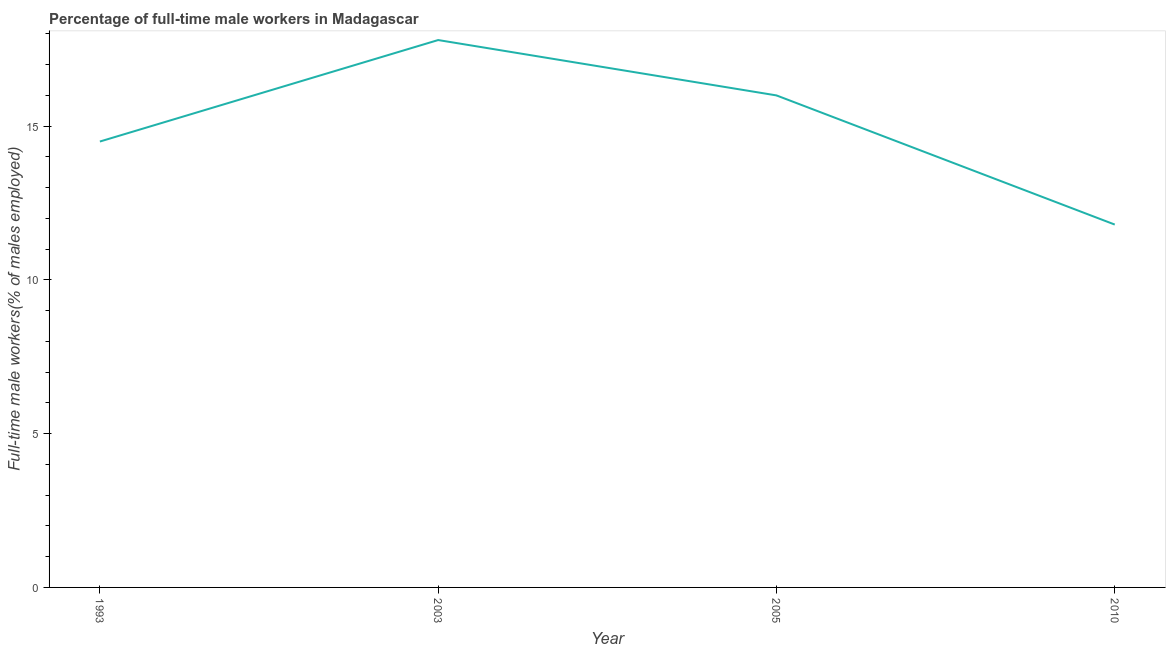What is the percentage of full-time male workers in 2010?
Ensure brevity in your answer.  11.8. Across all years, what is the maximum percentage of full-time male workers?
Ensure brevity in your answer.  17.8. Across all years, what is the minimum percentage of full-time male workers?
Ensure brevity in your answer.  11.8. In which year was the percentage of full-time male workers maximum?
Provide a short and direct response. 2003. What is the sum of the percentage of full-time male workers?
Provide a short and direct response. 60.1. What is the difference between the percentage of full-time male workers in 1993 and 2003?
Make the answer very short. -3.3. What is the average percentage of full-time male workers per year?
Provide a short and direct response. 15.02. What is the median percentage of full-time male workers?
Provide a short and direct response. 15.25. In how many years, is the percentage of full-time male workers greater than 14 %?
Make the answer very short. 3. Do a majority of the years between 2010 and 1993 (inclusive) have percentage of full-time male workers greater than 2 %?
Make the answer very short. Yes. What is the ratio of the percentage of full-time male workers in 1993 to that in 2010?
Your answer should be very brief. 1.23. What is the difference between the highest and the second highest percentage of full-time male workers?
Your answer should be very brief. 1.8. What is the difference between the highest and the lowest percentage of full-time male workers?
Make the answer very short. 6. In how many years, is the percentage of full-time male workers greater than the average percentage of full-time male workers taken over all years?
Provide a succinct answer. 2. How many lines are there?
Ensure brevity in your answer.  1. How many years are there in the graph?
Your answer should be compact. 4. Does the graph contain grids?
Your answer should be compact. No. What is the title of the graph?
Your response must be concise. Percentage of full-time male workers in Madagascar. What is the label or title of the Y-axis?
Give a very brief answer. Full-time male workers(% of males employed). What is the Full-time male workers(% of males employed) in 1993?
Your answer should be very brief. 14.5. What is the Full-time male workers(% of males employed) in 2003?
Your answer should be compact. 17.8. What is the Full-time male workers(% of males employed) in 2005?
Provide a short and direct response. 16. What is the Full-time male workers(% of males employed) of 2010?
Your response must be concise. 11.8. What is the difference between the Full-time male workers(% of males employed) in 1993 and 2003?
Your response must be concise. -3.3. What is the difference between the Full-time male workers(% of males employed) in 2005 and 2010?
Offer a very short reply. 4.2. What is the ratio of the Full-time male workers(% of males employed) in 1993 to that in 2003?
Make the answer very short. 0.81. What is the ratio of the Full-time male workers(% of males employed) in 1993 to that in 2005?
Keep it short and to the point. 0.91. What is the ratio of the Full-time male workers(% of males employed) in 1993 to that in 2010?
Keep it short and to the point. 1.23. What is the ratio of the Full-time male workers(% of males employed) in 2003 to that in 2005?
Your response must be concise. 1.11. What is the ratio of the Full-time male workers(% of males employed) in 2003 to that in 2010?
Ensure brevity in your answer.  1.51. What is the ratio of the Full-time male workers(% of males employed) in 2005 to that in 2010?
Your answer should be very brief. 1.36. 